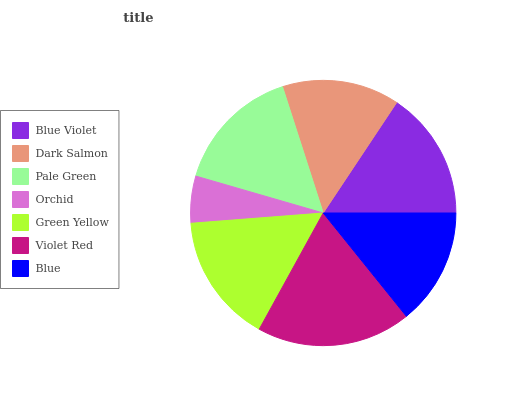Is Orchid the minimum?
Answer yes or no. Yes. Is Violet Red the maximum?
Answer yes or no. Yes. Is Dark Salmon the minimum?
Answer yes or no. No. Is Dark Salmon the maximum?
Answer yes or no. No. Is Blue Violet greater than Dark Salmon?
Answer yes or no. Yes. Is Dark Salmon less than Blue Violet?
Answer yes or no. Yes. Is Dark Salmon greater than Blue Violet?
Answer yes or no. No. Is Blue Violet less than Dark Salmon?
Answer yes or no. No. Is Pale Green the high median?
Answer yes or no. Yes. Is Pale Green the low median?
Answer yes or no. Yes. Is Orchid the high median?
Answer yes or no. No. Is Blue the low median?
Answer yes or no. No. 